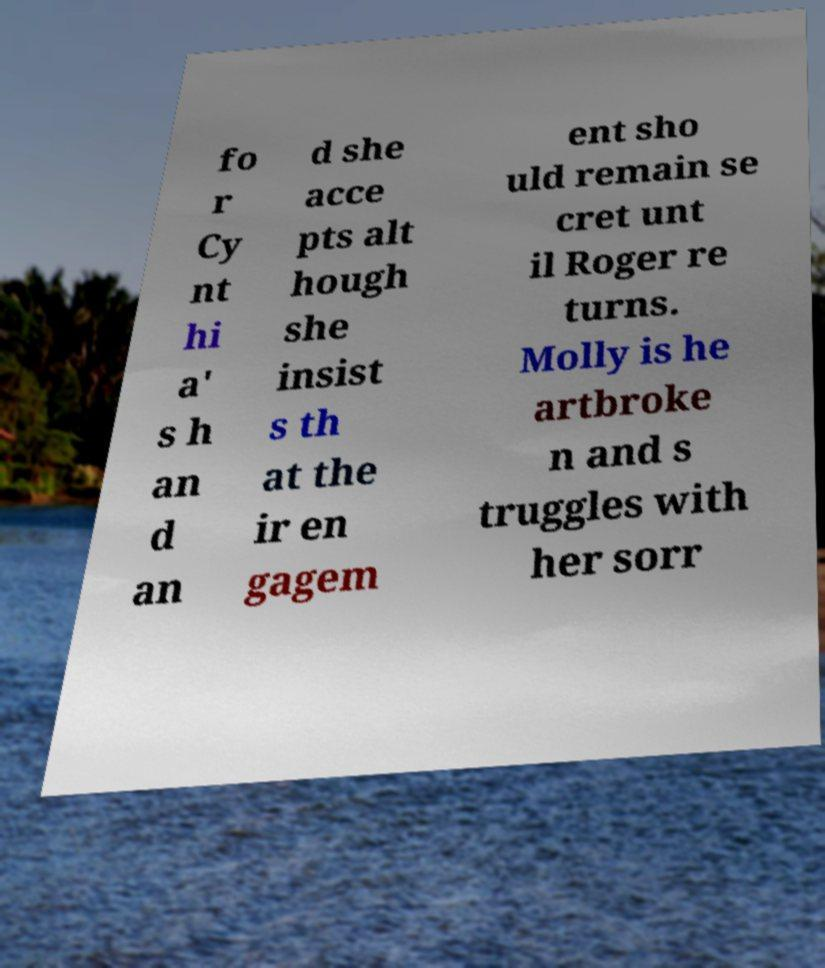Please identify and transcribe the text found in this image. fo r Cy nt hi a' s h an d an d she acce pts alt hough she insist s th at the ir en gagem ent sho uld remain se cret unt il Roger re turns. Molly is he artbroke n and s truggles with her sorr 